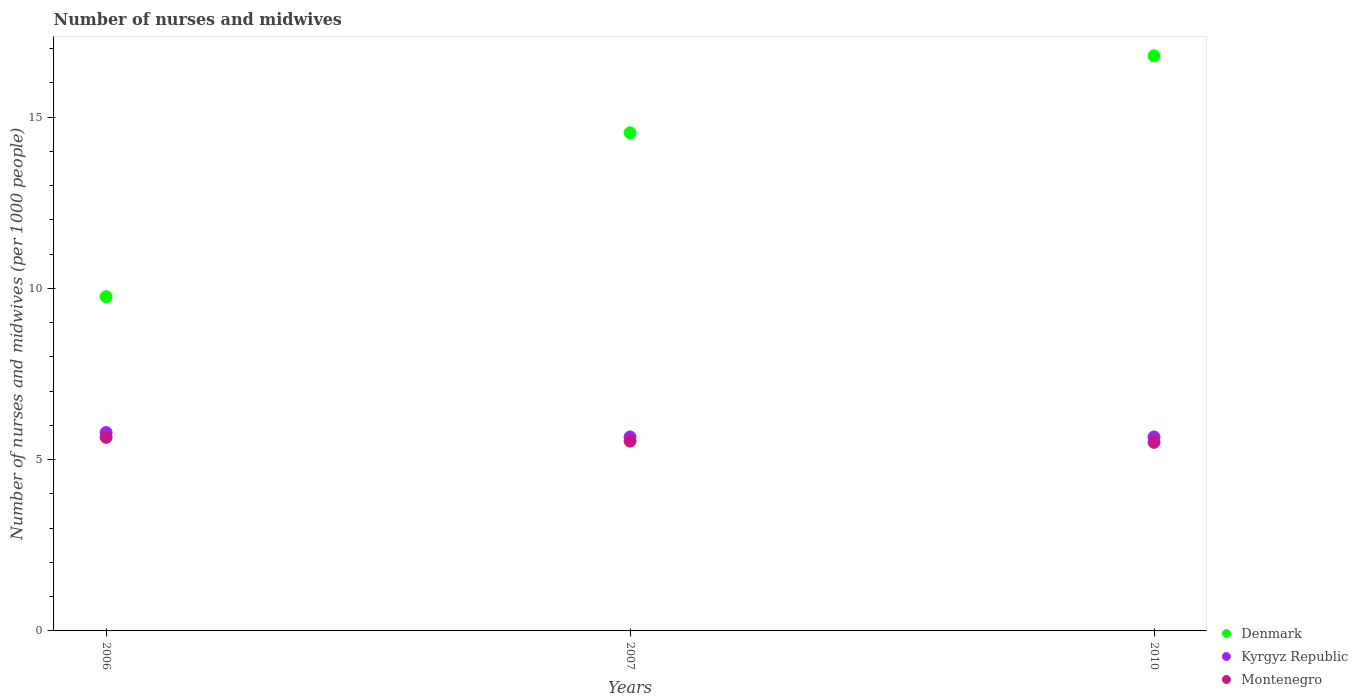Is the number of dotlines equal to the number of legend labels?
Offer a very short reply. Yes. What is the number of nurses and midwives in in Kyrgyz Republic in 2006?
Your answer should be very brief. 5.79. Across all years, what is the maximum number of nurses and midwives in in Kyrgyz Republic?
Your answer should be very brief. 5.79. Across all years, what is the minimum number of nurses and midwives in in Denmark?
Make the answer very short. 9.76. In which year was the number of nurses and midwives in in Denmark maximum?
Offer a very short reply. 2010. What is the total number of nurses and midwives in in Montenegro in the graph?
Keep it short and to the point. 16.7. What is the difference between the number of nurses and midwives in in Montenegro in 2007 and that in 2010?
Offer a very short reply. 0.04. What is the difference between the number of nurses and midwives in in Kyrgyz Republic in 2006 and the number of nurses and midwives in in Denmark in 2007?
Your answer should be compact. -8.75. What is the average number of nurses and midwives in in Kyrgyz Republic per year?
Offer a terse response. 5.7. In the year 2010, what is the difference between the number of nurses and midwives in in Denmark and number of nurses and midwives in in Montenegro?
Ensure brevity in your answer.  11.28. In how many years, is the number of nurses and midwives in in Denmark greater than 3?
Make the answer very short. 3. What is the ratio of the number of nurses and midwives in in Denmark in 2007 to that in 2010?
Your answer should be compact. 0.87. Is the number of nurses and midwives in in Denmark in 2007 less than that in 2010?
Your answer should be compact. Yes. What is the difference between the highest and the second highest number of nurses and midwives in in Denmark?
Ensure brevity in your answer.  2.25. What is the difference between the highest and the lowest number of nurses and midwives in in Denmark?
Provide a succinct answer. 7.03. Is the sum of the number of nurses and midwives in in Denmark in 2006 and 2007 greater than the maximum number of nurses and midwives in in Montenegro across all years?
Your answer should be compact. Yes. Is it the case that in every year, the sum of the number of nurses and midwives in in Kyrgyz Republic and number of nurses and midwives in in Montenegro  is greater than the number of nurses and midwives in in Denmark?
Provide a short and direct response. No. Is the number of nurses and midwives in in Montenegro strictly greater than the number of nurses and midwives in in Kyrgyz Republic over the years?
Your answer should be compact. No. Is the number of nurses and midwives in in Kyrgyz Republic strictly less than the number of nurses and midwives in in Denmark over the years?
Keep it short and to the point. Yes. How many years are there in the graph?
Make the answer very short. 3. Are the values on the major ticks of Y-axis written in scientific E-notation?
Your answer should be very brief. No. Does the graph contain any zero values?
Make the answer very short. No. Does the graph contain grids?
Give a very brief answer. No. Where does the legend appear in the graph?
Ensure brevity in your answer.  Bottom right. What is the title of the graph?
Give a very brief answer. Number of nurses and midwives. Does "Belgium" appear as one of the legend labels in the graph?
Provide a short and direct response. No. What is the label or title of the Y-axis?
Your response must be concise. Number of nurses and midwives (per 1000 people). What is the Number of nurses and midwives (per 1000 people) of Denmark in 2006?
Make the answer very short. 9.76. What is the Number of nurses and midwives (per 1000 people) of Kyrgyz Republic in 2006?
Ensure brevity in your answer.  5.79. What is the Number of nurses and midwives (per 1000 people) of Montenegro in 2006?
Your response must be concise. 5.65. What is the Number of nurses and midwives (per 1000 people) in Denmark in 2007?
Your answer should be very brief. 14.54. What is the Number of nurses and midwives (per 1000 people) of Kyrgyz Republic in 2007?
Provide a short and direct response. 5.66. What is the Number of nurses and midwives (per 1000 people) of Montenegro in 2007?
Offer a very short reply. 5.54. What is the Number of nurses and midwives (per 1000 people) in Denmark in 2010?
Your response must be concise. 16.79. What is the Number of nurses and midwives (per 1000 people) of Kyrgyz Republic in 2010?
Give a very brief answer. 5.66. What is the Number of nurses and midwives (per 1000 people) in Montenegro in 2010?
Your answer should be compact. 5.5. Across all years, what is the maximum Number of nurses and midwives (per 1000 people) in Denmark?
Your answer should be very brief. 16.79. Across all years, what is the maximum Number of nurses and midwives (per 1000 people) of Kyrgyz Republic?
Provide a short and direct response. 5.79. Across all years, what is the maximum Number of nurses and midwives (per 1000 people) in Montenegro?
Offer a terse response. 5.65. Across all years, what is the minimum Number of nurses and midwives (per 1000 people) in Denmark?
Your answer should be compact. 9.76. Across all years, what is the minimum Number of nurses and midwives (per 1000 people) in Kyrgyz Republic?
Give a very brief answer. 5.66. Across all years, what is the minimum Number of nurses and midwives (per 1000 people) in Montenegro?
Offer a terse response. 5.5. What is the total Number of nurses and midwives (per 1000 people) in Denmark in the graph?
Offer a very short reply. 41.08. What is the total Number of nurses and midwives (per 1000 people) in Kyrgyz Republic in the graph?
Keep it short and to the point. 17.11. What is the total Number of nurses and midwives (per 1000 people) of Montenegro in the graph?
Your answer should be compact. 16.7. What is the difference between the Number of nurses and midwives (per 1000 people) of Denmark in 2006 and that in 2007?
Offer a terse response. -4.78. What is the difference between the Number of nurses and midwives (per 1000 people) of Kyrgyz Republic in 2006 and that in 2007?
Offer a terse response. 0.13. What is the difference between the Number of nurses and midwives (per 1000 people) in Montenegro in 2006 and that in 2007?
Your response must be concise. 0.11. What is the difference between the Number of nurses and midwives (per 1000 people) in Denmark in 2006 and that in 2010?
Provide a short and direct response. -7.03. What is the difference between the Number of nurses and midwives (per 1000 people) in Kyrgyz Republic in 2006 and that in 2010?
Keep it short and to the point. 0.13. What is the difference between the Number of nurses and midwives (per 1000 people) in Montenegro in 2006 and that in 2010?
Your answer should be very brief. 0.14. What is the difference between the Number of nurses and midwives (per 1000 people) in Denmark in 2007 and that in 2010?
Provide a succinct answer. -2.25. What is the difference between the Number of nurses and midwives (per 1000 people) of Montenegro in 2007 and that in 2010?
Give a very brief answer. 0.04. What is the difference between the Number of nurses and midwives (per 1000 people) in Denmark in 2006 and the Number of nurses and midwives (per 1000 people) in Kyrgyz Republic in 2007?
Give a very brief answer. 4.09. What is the difference between the Number of nurses and midwives (per 1000 people) in Denmark in 2006 and the Number of nurses and midwives (per 1000 people) in Montenegro in 2007?
Offer a terse response. 4.22. What is the difference between the Number of nurses and midwives (per 1000 people) of Kyrgyz Republic in 2006 and the Number of nurses and midwives (per 1000 people) of Montenegro in 2007?
Ensure brevity in your answer.  0.25. What is the difference between the Number of nurses and midwives (per 1000 people) in Denmark in 2006 and the Number of nurses and midwives (per 1000 people) in Kyrgyz Republic in 2010?
Offer a very short reply. 4.09. What is the difference between the Number of nurses and midwives (per 1000 people) in Denmark in 2006 and the Number of nurses and midwives (per 1000 people) in Montenegro in 2010?
Give a very brief answer. 4.25. What is the difference between the Number of nurses and midwives (per 1000 people) of Kyrgyz Republic in 2006 and the Number of nurses and midwives (per 1000 people) of Montenegro in 2010?
Your response must be concise. 0.28. What is the difference between the Number of nurses and midwives (per 1000 people) of Denmark in 2007 and the Number of nurses and midwives (per 1000 people) of Kyrgyz Republic in 2010?
Keep it short and to the point. 8.88. What is the difference between the Number of nurses and midwives (per 1000 people) in Denmark in 2007 and the Number of nurses and midwives (per 1000 people) in Montenegro in 2010?
Offer a terse response. 9.04. What is the difference between the Number of nurses and midwives (per 1000 people) in Kyrgyz Republic in 2007 and the Number of nurses and midwives (per 1000 people) in Montenegro in 2010?
Keep it short and to the point. 0.16. What is the average Number of nurses and midwives (per 1000 people) of Denmark per year?
Your response must be concise. 13.69. What is the average Number of nurses and midwives (per 1000 people) in Kyrgyz Republic per year?
Keep it short and to the point. 5.7. What is the average Number of nurses and midwives (per 1000 people) of Montenegro per year?
Your answer should be very brief. 5.57. In the year 2006, what is the difference between the Number of nurses and midwives (per 1000 people) of Denmark and Number of nurses and midwives (per 1000 people) of Kyrgyz Republic?
Give a very brief answer. 3.97. In the year 2006, what is the difference between the Number of nurses and midwives (per 1000 people) of Denmark and Number of nurses and midwives (per 1000 people) of Montenegro?
Offer a very short reply. 4.11. In the year 2006, what is the difference between the Number of nurses and midwives (per 1000 people) of Kyrgyz Republic and Number of nurses and midwives (per 1000 people) of Montenegro?
Your response must be concise. 0.14. In the year 2007, what is the difference between the Number of nurses and midwives (per 1000 people) in Denmark and Number of nurses and midwives (per 1000 people) in Kyrgyz Republic?
Provide a short and direct response. 8.88. In the year 2007, what is the difference between the Number of nurses and midwives (per 1000 people) in Kyrgyz Republic and Number of nurses and midwives (per 1000 people) in Montenegro?
Offer a terse response. 0.12. In the year 2010, what is the difference between the Number of nurses and midwives (per 1000 people) in Denmark and Number of nurses and midwives (per 1000 people) in Kyrgyz Republic?
Provide a short and direct response. 11.12. In the year 2010, what is the difference between the Number of nurses and midwives (per 1000 people) of Denmark and Number of nurses and midwives (per 1000 people) of Montenegro?
Make the answer very short. 11.28. In the year 2010, what is the difference between the Number of nurses and midwives (per 1000 people) in Kyrgyz Republic and Number of nurses and midwives (per 1000 people) in Montenegro?
Make the answer very short. 0.16. What is the ratio of the Number of nurses and midwives (per 1000 people) of Denmark in 2006 to that in 2007?
Provide a succinct answer. 0.67. What is the ratio of the Number of nurses and midwives (per 1000 people) of Kyrgyz Republic in 2006 to that in 2007?
Offer a very short reply. 1.02. What is the ratio of the Number of nurses and midwives (per 1000 people) in Montenegro in 2006 to that in 2007?
Your response must be concise. 1.02. What is the ratio of the Number of nurses and midwives (per 1000 people) of Denmark in 2006 to that in 2010?
Your response must be concise. 0.58. What is the ratio of the Number of nurses and midwives (per 1000 people) in Kyrgyz Republic in 2006 to that in 2010?
Ensure brevity in your answer.  1.02. What is the ratio of the Number of nurses and midwives (per 1000 people) in Montenegro in 2006 to that in 2010?
Ensure brevity in your answer.  1.03. What is the ratio of the Number of nurses and midwives (per 1000 people) in Denmark in 2007 to that in 2010?
Your answer should be very brief. 0.87. What is the ratio of the Number of nurses and midwives (per 1000 people) of Kyrgyz Republic in 2007 to that in 2010?
Keep it short and to the point. 1. What is the ratio of the Number of nurses and midwives (per 1000 people) in Montenegro in 2007 to that in 2010?
Give a very brief answer. 1.01. What is the difference between the highest and the second highest Number of nurses and midwives (per 1000 people) in Denmark?
Provide a short and direct response. 2.25. What is the difference between the highest and the second highest Number of nurses and midwives (per 1000 people) in Kyrgyz Republic?
Ensure brevity in your answer.  0.13. What is the difference between the highest and the second highest Number of nurses and midwives (per 1000 people) in Montenegro?
Offer a terse response. 0.11. What is the difference between the highest and the lowest Number of nurses and midwives (per 1000 people) in Denmark?
Make the answer very short. 7.03. What is the difference between the highest and the lowest Number of nurses and midwives (per 1000 people) of Kyrgyz Republic?
Make the answer very short. 0.13. What is the difference between the highest and the lowest Number of nurses and midwives (per 1000 people) of Montenegro?
Keep it short and to the point. 0.14. 